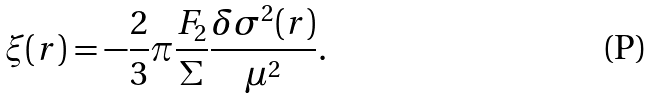Convert formula to latex. <formula><loc_0><loc_0><loc_500><loc_500>\xi ( r ) = - \frac { 2 } { 3 } \pi \frac { F _ { 2 } } { \Sigma } \frac { \delta \sigma ^ { 2 } ( r ) } { \mu ^ { 2 } } .</formula> 